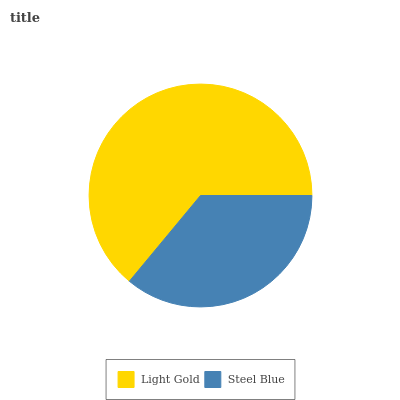Is Steel Blue the minimum?
Answer yes or no. Yes. Is Light Gold the maximum?
Answer yes or no. Yes. Is Steel Blue the maximum?
Answer yes or no. No. Is Light Gold greater than Steel Blue?
Answer yes or no. Yes. Is Steel Blue less than Light Gold?
Answer yes or no. Yes. Is Steel Blue greater than Light Gold?
Answer yes or no. No. Is Light Gold less than Steel Blue?
Answer yes or no. No. Is Light Gold the high median?
Answer yes or no. Yes. Is Steel Blue the low median?
Answer yes or no. Yes. Is Steel Blue the high median?
Answer yes or no. No. Is Light Gold the low median?
Answer yes or no. No. 